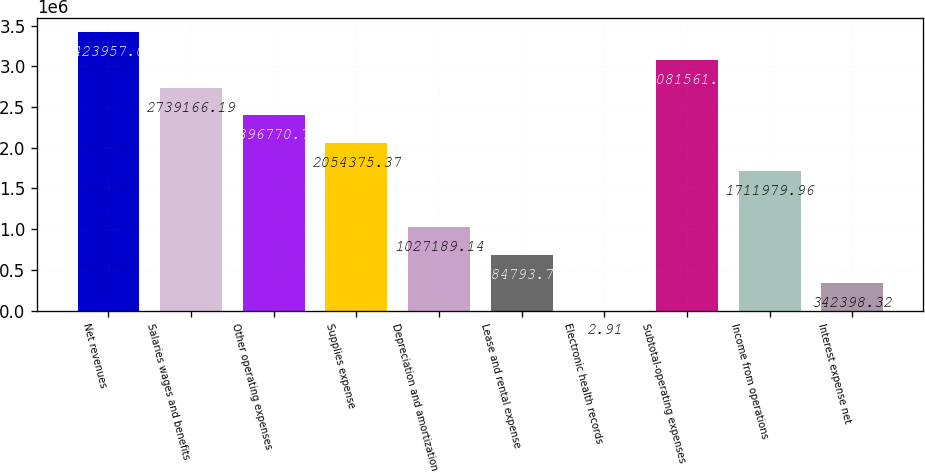Convert chart to OTSL. <chart><loc_0><loc_0><loc_500><loc_500><bar_chart><fcel>Net revenues<fcel>Salaries wages and benefits<fcel>Other operating expenses<fcel>Supplies expense<fcel>Depreciation and amortization<fcel>Lease and rental expense<fcel>Electronic health records<fcel>Subtotal-operating expenses<fcel>Income from operations<fcel>Interest expense net<nl><fcel>3.42396e+06<fcel>2.73917e+06<fcel>2.39677e+06<fcel>2.05438e+06<fcel>1.02719e+06<fcel>684794<fcel>2.91<fcel>3.08156e+06<fcel>1.71198e+06<fcel>342398<nl></chart> 